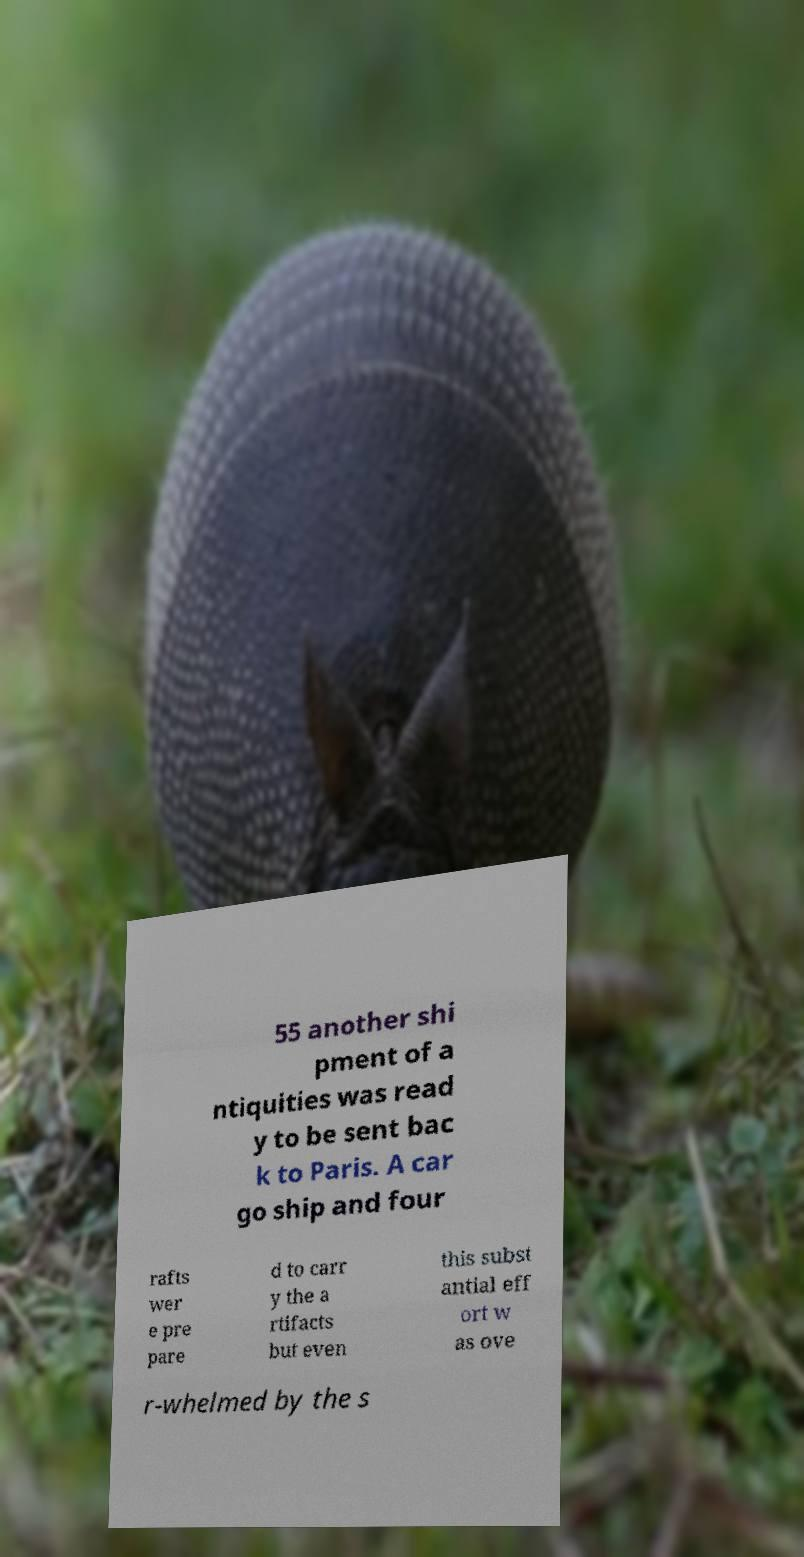Could you extract and type out the text from this image? 55 another shi pment of a ntiquities was read y to be sent bac k to Paris. A car go ship and four rafts wer e pre pare d to carr y the a rtifacts but even this subst antial eff ort w as ove r-whelmed by the s 